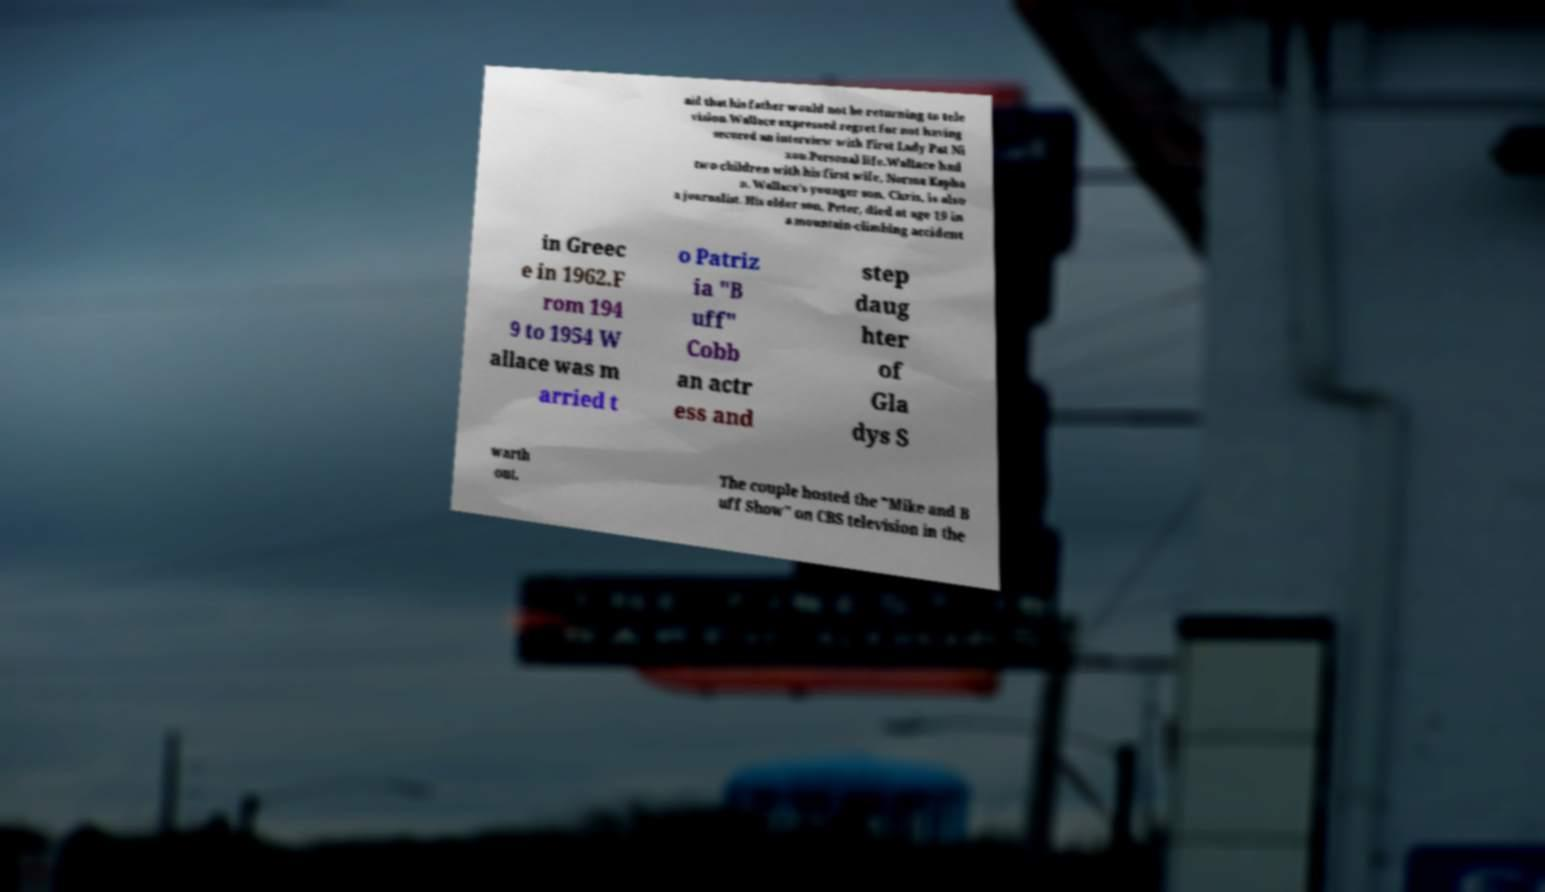What messages or text are displayed in this image? I need them in a readable, typed format. aid that his father would not be returning to tele vision.Wallace expressed regret for not having secured an interview with First Lady Pat Ni xon.Personal life.Wallace had two children with his first wife, Norma Kapha n. Wallace's younger son, Chris, is also a journalist. His elder son, Peter, died at age 19 in a mountain-climbing accident in Greec e in 1962.F rom 194 9 to 1954 W allace was m arried t o Patriz ia "B uff" Cobb an actr ess and step daug hter of Gla dys S warth out. The couple hosted the "Mike and B uff Show" on CBS television in the 